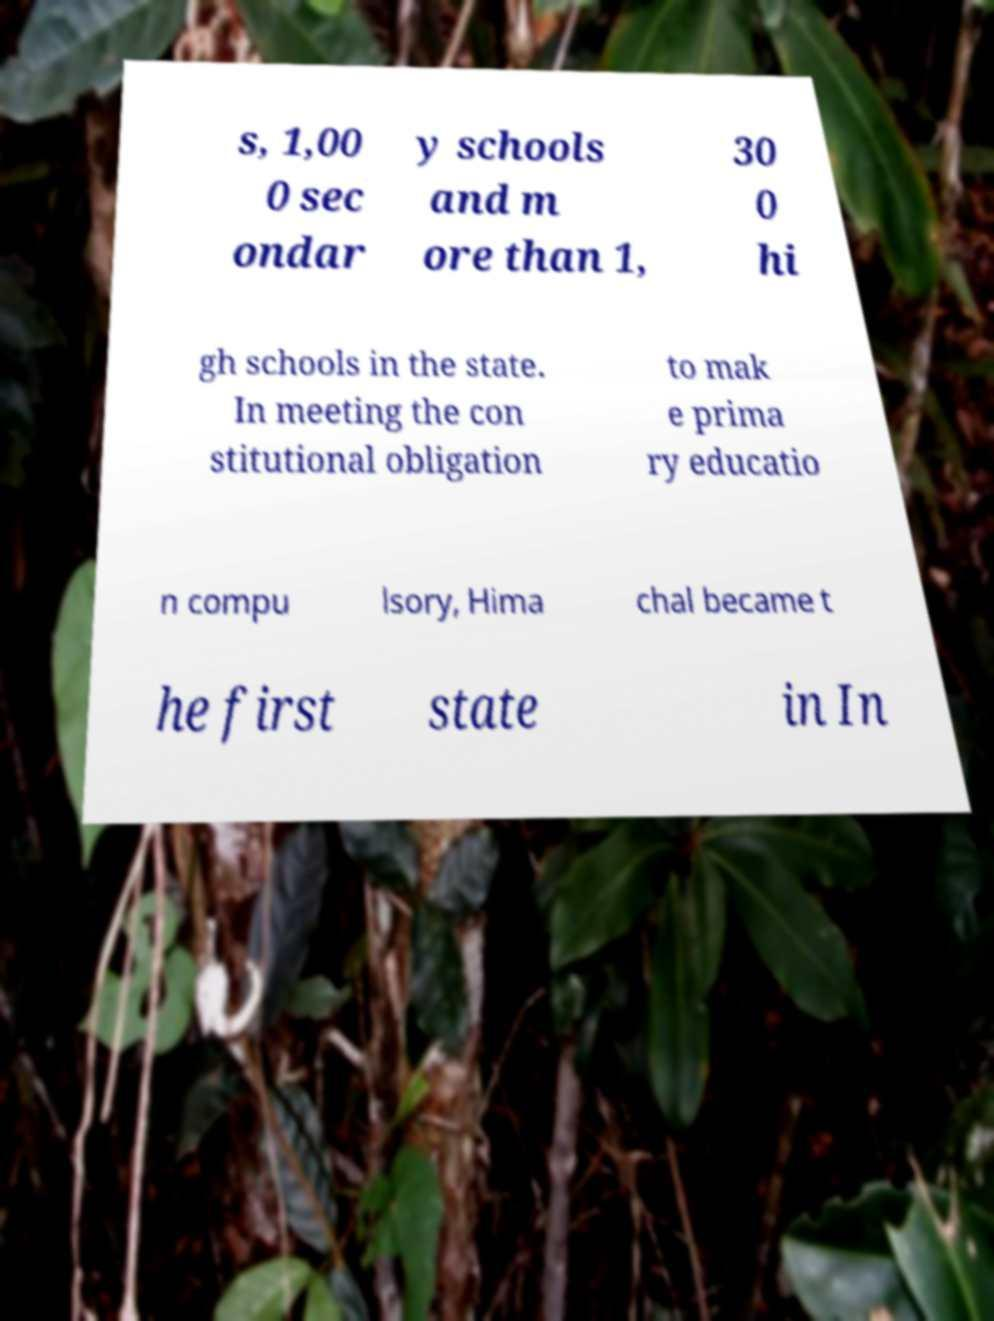Can you accurately transcribe the text from the provided image for me? s, 1,00 0 sec ondar y schools and m ore than 1, 30 0 hi gh schools in the state. In meeting the con stitutional obligation to mak e prima ry educatio n compu lsory, Hima chal became t he first state in In 